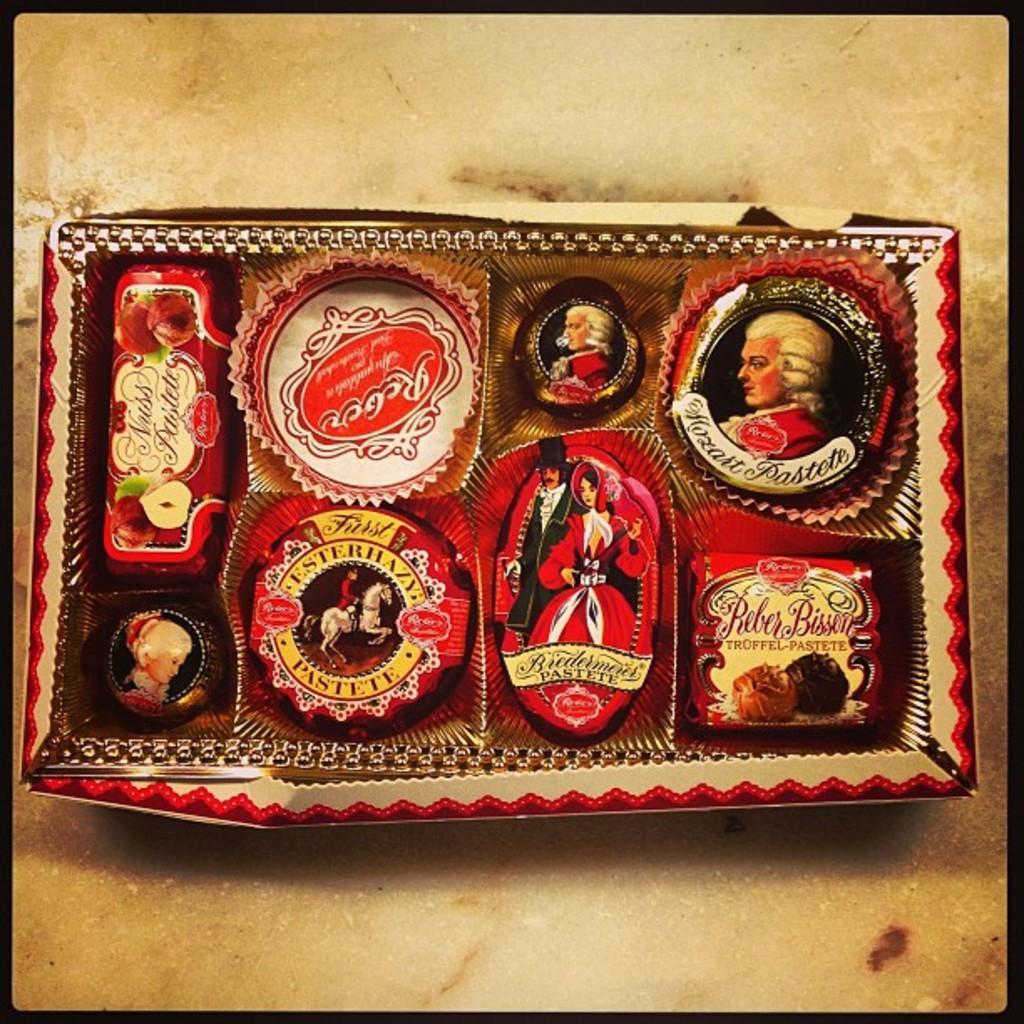Could you give a brief overview of what you see in this image? In this image we can see a frame placed on the surface. 